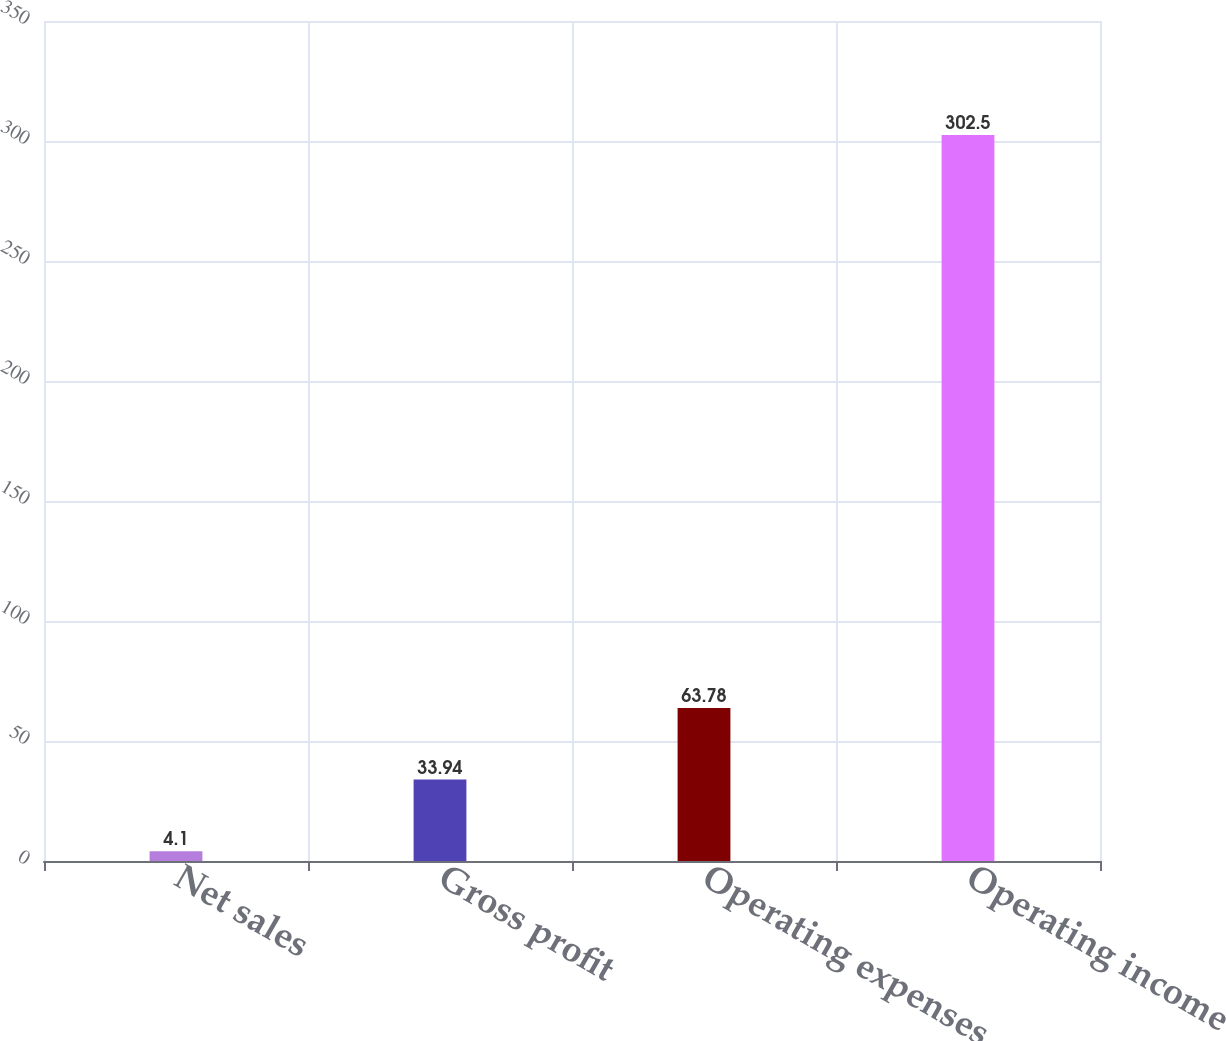Convert chart to OTSL. <chart><loc_0><loc_0><loc_500><loc_500><bar_chart><fcel>Net sales<fcel>Gross profit<fcel>Operating expenses<fcel>Operating income<nl><fcel>4.1<fcel>33.94<fcel>63.78<fcel>302.5<nl></chart> 